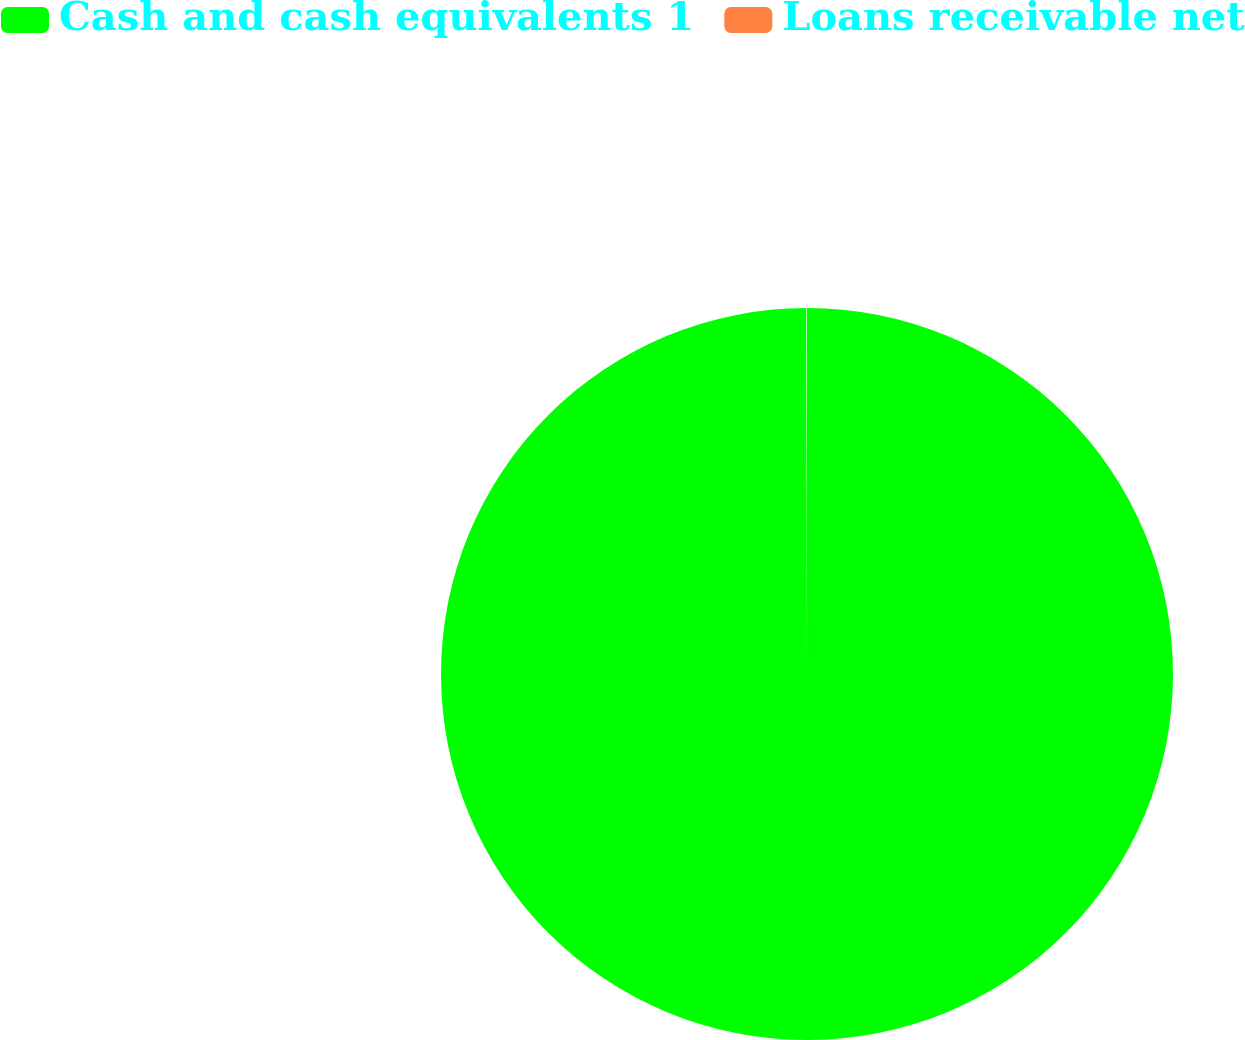Convert chart to OTSL. <chart><loc_0><loc_0><loc_500><loc_500><pie_chart><fcel>Cash and cash equivalents 1<fcel>Loans receivable net<nl><fcel>99.97%<fcel>0.03%<nl></chart> 